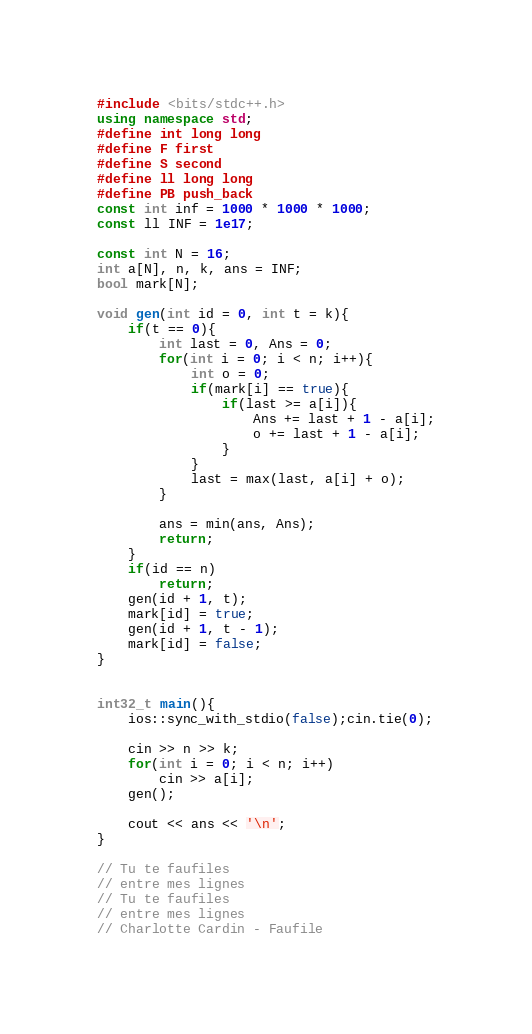<code> <loc_0><loc_0><loc_500><loc_500><_C++_>#include <bits/stdc++.h>
using namespace std;
#define int long long
#define F first
#define S second
#define ll long long
#define PB push_back
const int inf = 1000 * 1000 * 1000;
const ll INF = 1e17;

const int N = 16;
int a[N], n, k, ans = INF;
bool mark[N];

void gen(int id = 0, int t = k){
	if(t == 0){
		int last = 0, Ans = 0;
		for(int i = 0; i < n; i++){
			int o = 0;
			if(mark[i] == true){
				if(last >= a[i]){
					Ans += last + 1 - a[i];
					o += last + 1 - a[i];
				}
			}
			last = max(last, a[i] + o);
		}

		ans = min(ans, Ans);
		return;
	}
	if(id == n)
		return;
	gen(id + 1, t);
	mark[id] = true;
	gen(id + 1, t - 1);
	mark[id] = false;
}


int32_t main(){
	ios::sync_with_stdio(false);cin.tie(0);
	
	cin >> n >> k;
	for(int i = 0; i < n; i++)
		cin >> a[i];
	gen();
	
	cout << ans << '\n';
}

// Tu te faufiles
// entre mes lignes
// Tu te faufiles
// entre mes lignes
// Charlotte Cardin - Faufile</code> 